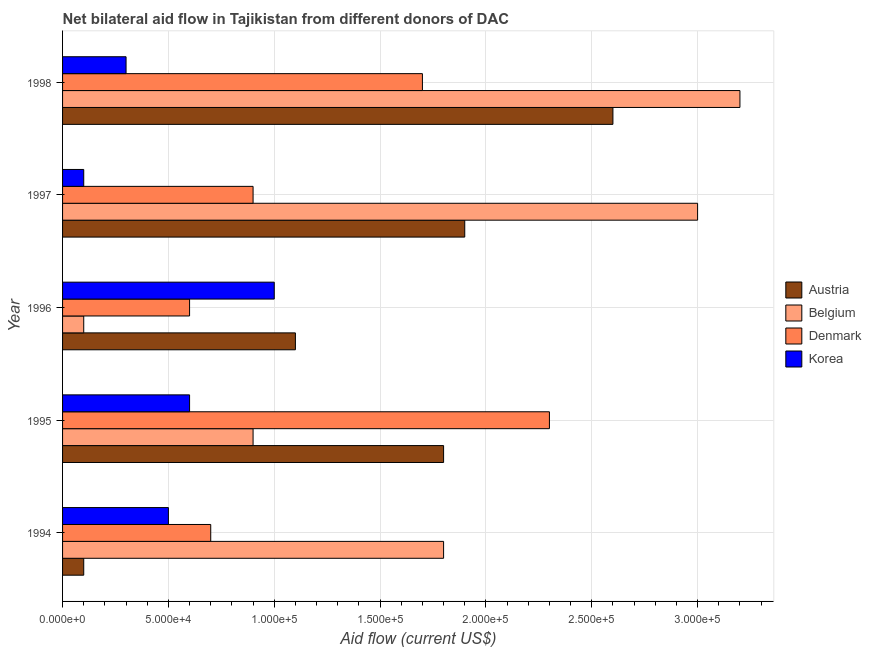How many different coloured bars are there?
Offer a terse response. 4. Are the number of bars per tick equal to the number of legend labels?
Your response must be concise. Yes. How many bars are there on the 1st tick from the top?
Provide a succinct answer. 4. How many bars are there on the 2nd tick from the bottom?
Make the answer very short. 4. What is the label of the 1st group of bars from the top?
Offer a terse response. 1998. What is the amount of aid given by korea in 1994?
Your answer should be very brief. 5.00e+04. Across all years, what is the maximum amount of aid given by korea?
Make the answer very short. 1.00e+05. Across all years, what is the minimum amount of aid given by austria?
Your response must be concise. 10000. What is the total amount of aid given by denmark in the graph?
Offer a very short reply. 6.20e+05. What is the difference between the amount of aid given by korea in 1996 and that in 1997?
Provide a succinct answer. 9.00e+04. What is the difference between the amount of aid given by austria in 1994 and the amount of aid given by denmark in 1996?
Offer a very short reply. -5.00e+04. In the year 1995, what is the difference between the amount of aid given by korea and amount of aid given by belgium?
Make the answer very short. -3.00e+04. In how many years, is the amount of aid given by korea greater than 40000 US$?
Provide a succinct answer. 3. Is the amount of aid given by korea in 1994 less than that in 1997?
Offer a very short reply. No. What is the difference between the highest and the second highest amount of aid given by korea?
Keep it short and to the point. 4.00e+04. What is the difference between the highest and the lowest amount of aid given by korea?
Ensure brevity in your answer.  9.00e+04. Is the sum of the amount of aid given by korea in 1995 and 1997 greater than the maximum amount of aid given by austria across all years?
Give a very brief answer. No. Is it the case that in every year, the sum of the amount of aid given by korea and amount of aid given by denmark is greater than the sum of amount of aid given by austria and amount of aid given by belgium?
Offer a very short reply. No. What does the 2nd bar from the top in 1997 represents?
Give a very brief answer. Denmark. What does the 1st bar from the bottom in 1997 represents?
Ensure brevity in your answer.  Austria. How many years are there in the graph?
Your answer should be very brief. 5. What is the difference between two consecutive major ticks on the X-axis?
Provide a short and direct response. 5.00e+04. Are the values on the major ticks of X-axis written in scientific E-notation?
Keep it short and to the point. Yes. Does the graph contain grids?
Your answer should be compact. Yes. Where does the legend appear in the graph?
Your answer should be very brief. Center right. How are the legend labels stacked?
Your answer should be very brief. Vertical. What is the title of the graph?
Your answer should be compact. Net bilateral aid flow in Tajikistan from different donors of DAC. What is the label or title of the X-axis?
Make the answer very short. Aid flow (current US$). What is the label or title of the Y-axis?
Provide a succinct answer. Year. What is the Aid flow (current US$) in Denmark in 1994?
Offer a very short reply. 7.00e+04. What is the Aid flow (current US$) in Korea in 1994?
Provide a short and direct response. 5.00e+04. What is the Aid flow (current US$) in Austria in 1995?
Your response must be concise. 1.80e+05. What is the Aid flow (current US$) in Denmark in 1995?
Give a very brief answer. 2.30e+05. What is the Aid flow (current US$) in Korea in 1995?
Your answer should be compact. 6.00e+04. What is the Aid flow (current US$) of Austria in 1996?
Your answer should be very brief. 1.10e+05. What is the Aid flow (current US$) of Belgium in 1997?
Provide a succinct answer. 3.00e+05. What is the Aid flow (current US$) of Denmark in 1997?
Your answer should be very brief. 9.00e+04. What is the Aid flow (current US$) of Korea in 1997?
Your answer should be very brief. 10000. What is the Aid flow (current US$) of Belgium in 1998?
Make the answer very short. 3.20e+05. Across all years, what is the maximum Aid flow (current US$) of Denmark?
Offer a terse response. 2.30e+05. Across all years, what is the maximum Aid flow (current US$) in Korea?
Keep it short and to the point. 1.00e+05. Across all years, what is the minimum Aid flow (current US$) in Austria?
Offer a very short reply. 10000. Across all years, what is the minimum Aid flow (current US$) in Belgium?
Ensure brevity in your answer.  10000. What is the total Aid flow (current US$) in Austria in the graph?
Your answer should be very brief. 7.50e+05. What is the total Aid flow (current US$) of Belgium in the graph?
Keep it short and to the point. 9.00e+05. What is the total Aid flow (current US$) in Denmark in the graph?
Provide a short and direct response. 6.20e+05. What is the difference between the Aid flow (current US$) of Austria in 1994 and that in 1995?
Ensure brevity in your answer.  -1.70e+05. What is the difference between the Aid flow (current US$) in Belgium in 1994 and that in 1995?
Keep it short and to the point. 9.00e+04. What is the difference between the Aid flow (current US$) in Korea in 1994 and that in 1995?
Your response must be concise. -10000. What is the difference between the Aid flow (current US$) in Belgium in 1994 and that in 1996?
Your response must be concise. 1.70e+05. What is the difference between the Aid flow (current US$) in Denmark in 1994 and that in 1996?
Ensure brevity in your answer.  10000. What is the difference between the Aid flow (current US$) in Belgium in 1994 and that in 1997?
Your answer should be compact. -1.20e+05. What is the difference between the Aid flow (current US$) in Denmark in 1994 and that in 1997?
Your answer should be compact. -2.00e+04. What is the difference between the Aid flow (current US$) of Korea in 1994 and that in 1997?
Your response must be concise. 4.00e+04. What is the difference between the Aid flow (current US$) in Austria in 1994 and that in 1998?
Ensure brevity in your answer.  -2.50e+05. What is the difference between the Aid flow (current US$) of Belgium in 1994 and that in 1998?
Provide a succinct answer. -1.40e+05. What is the difference between the Aid flow (current US$) of Korea in 1994 and that in 1998?
Provide a short and direct response. 2.00e+04. What is the difference between the Aid flow (current US$) of Austria in 1995 and that in 1996?
Your answer should be very brief. 7.00e+04. What is the difference between the Aid flow (current US$) of Belgium in 1995 and that in 1996?
Provide a short and direct response. 8.00e+04. What is the difference between the Aid flow (current US$) of Denmark in 1995 and that in 1996?
Provide a succinct answer. 1.70e+05. What is the difference between the Aid flow (current US$) in Korea in 1995 and that in 1996?
Keep it short and to the point. -4.00e+04. What is the difference between the Aid flow (current US$) of Austria in 1995 and that in 1997?
Your answer should be compact. -10000. What is the difference between the Aid flow (current US$) of Korea in 1995 and that in 1997?
Offer a very short reply. 5.00e+04. What is the difference between the Aid flow (current US$) in Korea in 1995 and that in 1998?
Provide a succinct answer. 3.00e+04. What is the difference between the Aid flow (current US$) of Denmark in 1996 and that in 1997?
Keep it short and to the point. -3.00e+04. What is the difference between the Aid flow (current US$) of Austria in 1996 and that in 1998?
Give a very brief answer. -1.50e+05. What is the difference between the Aid flow (current US$) in Belgium in 1996 and that in 1998?
Make the answer very short. -3.10e+05. What is the difference between the Aid flow (current US$) of Denmark in 1996 and that in 1998?
Ensure brevity in your answer.  -1.10e+05. What is the difference between the Aid flow (current US$) of Austria in 1994 and the Aid flow (current US$) of Belgium in 1995?
Offer a very short reply. -8.00e+04. What is the difference between the Aid flow (current US$) in Austria in 1994 and the Aid flow (current US$) in Denmark in 1995?
Your answer should be very brief. -2.20e+05. What is the difference between the Aid flow (current US$) of Austria in 1994 and the Aid flow (current US$) of Korea in 1995?
Offer a very short reply. -5.00e+04. What is the difference between the Aid flow (current US$) in Belgium in 1994 and the Aid flow (current US$) in Denmark in 1996?
Offer a terse response. 1.20e+05. What is the difference between the Aid flow (current US$) of Belgium in 1994 and the Aid flow (current US$) of Korea in 1996?
Ensure brevity in your answer.  8.00e+04. What is the difference between the Aid flow (current US$) in Denmark in 1994 and the Aid flow (current US$) in Korea in 1996?
Your answer should be very brief. -3.00e+04. What is the difference between the Aid flow (current US$) in Austria in 1994 and the Aid flow (current US$) in Korea in 1997?
Your answer should be very brief. 0. What is the difference between the Aid flow (current US$) of Denmark in 1994 and the Aid flow (current US$) of Korea in 1997?
Your response must be concise. 6.00e+04. What is the difference between the Aid flow (current US$) in Austria in 1994 and the Aid flow (current US$) in Belgium in 1998?
Offer a very short reply. -3.10e+05. What is the difference between the Aid flow (current US$) of Austria in 1994 and the Aid flow (current US$) of Denmark in 1998?
Your answer should be very brief. -1.60e+05. What is the difference between the Aid flow (current US$) of Belgium in 1994 and the Aid flow (current US$) of Korea in 1998?
Provide a short and direct response. 1.50e+05. What is the difference between the Aid flow (current US$) in Austria in 1995 and the Aid flow (current US$) in Belgium in 1996?
Ensure brevity in your answer.  1.70e+05. What is the difference between the Aid flow (current US$) of Belgium in 1995 and the Aid flow (current US$) of Denmark in 1996?
Your response must be concise. 3.00e+04. What is the difference between the Aid flow (current US$) in Belgium in 1995 and the Aid flow (current US$) in Korea in 1996?
Provide a short and direct response. -10000. What is the difference between the Aid flow (current US$) of Austria in 1995 and the Aid flow (current US$) of Denmark in 1997?
Ensure brevity in your answer.  9.00e+04. What is the difference between the Aid flow (current US$) in Belgium in 1995 and the Aid flow (current US$) in Denmark in 1997?
Provide a succinct answer. 0. What is the difference between the Aid flow (current US$) in Belgium in 1995 and the Aid flow (current US$) in Korea in 1997?
Offer a very short reply. 8.00e+04. What is the difference between the Aid flow (current US$) in Austria in 1995 and the Aid flow (current US$) in Korea in 1998?
Your answer should be very brief. 1.50e+05. What is the difference between the Aid flow (current US$) of Belgium in 1995 and the Aid flow (current US$) of Denmark in 1998?
Your answer should be compact. -8.00e+04. What is the difference between the Aid flow (current US$) in Belgium in 1995 and the Aid flow (current US$) in Korea in 1998?
Offer a very short reply. 6.00e+04. What is the difference between the Aid flow (current US$) in Denmark in 1995 and the Aid flow (current US$) in Korea in 1998?
Your response must be concise. 2.00e+05. What is the difference between the Aid flow (current US$) of Austria in 1996 and the Aid flow (current US$) of Belgium in 1997?
Offer a terse response. -1.90e+05. What is the difference between the Aid flow (current US$) in Austria in 1996 and the Aid flow (current US$) in Denmark in 1997?
Provide a succinct answer. 2.00e+04. What is the difference between the Aid flow (current US$) of Belgium in 1996 and the Aid flow (current US$) of Denmark in 1997?
Provide a succinct answer. -8.00e+04. What is the difference between the Aid flow (current US$) of Denmark in 1996 and the Aid flow (current US$) of Korea in 1997?
Your answer should be very brief. 5.00e+04. What is the difference between the Aid flow (current US$) of Austria in 1996 and the Aid flow (current US$) of Belgium in 1998?
Offer a terse response. -2.10e+05. What is the difference between the Aid flow (current US$) in Austria in 1996 and the Aid flow (current US$) in Denmark in 1998?
Offer a very short reply. -6.00e+04. What is the difference between the Aid flow (current US$) of Austria in 1996 and the Aid flow (current US$) of Korea in 1998?
Provide a short and direct response. 8.00e+04. What is the difference between the Aid flow (current US$) in Belgium in 1996 and the Aid flow (current US$) in Denmark in 1998?
Your answer should be very brief. -1.60e+05. What is the difference between the Aid flow (current US$) of Belgium in 1996 and the Aid flow (current US$) of Korea in 1998?
Ensure brevity in your answer.  -2.00e+04. What is the difference between the Aid flow (current US$) of Denmark in 1996 and the Aid flow (current US$) of Korea in 1998?
Provide a short and direct response. 3.00e+04. What is the difference between the Aid flow (current US$) of Belgium in 1997 and the Aid flow (current US$) of Korea in 1998?
Provide a short and direct response. 2.70e+05. What is the average Aid flow (current US$) in Austria per year?
Ensure brevity in your answer.  1.50e+05. What is the average Aid flow (current US$) of Denmark per year?
Provide a short and direct response. 1.24e+05. In the year 1994, what is the difference between the Aid flow (current US$) in Belgium and Aid flow (current US$) in Denmark?
Offer a terse response. 1.10e+05. In the year 1995, what is the difference between the Aid flow (current US$) of Belgium and Aid flow (current US$) of Korea?
Ensure brevity in your answer.  3.00e+04. In the year 1995, what is the difference between the Aid flow (current US$) of Denmark and Aid flow (current US$) of Korea?
Provide a succinct answer. 1.70e+05. In the year 1996, what is the difference between the Aid flow (current US$) in Austria and Aid flow (current US$) in Denmark?
Keep it short and to the point. 5.00e+04. In the year 1996, what is the difference between the Aid flow (current US$) in Austria and Aid flow (current US$) in Korea?
Your response must be concise. 10000. In the year 1996, what is the difference between the Aid flow (current US$) of Belgium and Aid flow (current US$) of Denmark?
Give a very brief answer. -5.00e+04. In the year 1997, what is the difference between the Aid flow (current US$) in Austria and Aid flow (current US$) in Belgium?
Ensure brevity in your answer.  -1.10e+05. In the year 1997, what is the difference between the Aid flow (current US$) in Austria and Aid flow (current US$) in Denmark?
Offer a terse response. 1.00e+05. In the year 1997, what is the difference between the Aid flow (current US$) of Austria and Aid flow (current US$) of Korea?
Your response must be concise. 1.80e+05. In the year 1997, what is the difference between the Aid flow (current US$) in Belgium and Aid flow (current US$) in Denmark?
Ensure brevity in your answer.  2.10e+05. In the year 1997, what is the difference between the Aid flow (current US$) of Belgium and Aid flow (current US$) of Korea?
Give a very brief answer. 2.90e+05. In the year 1998, what is the difference between the Aid flow (current US$) of Austria and Aid flow (current US$) of Belgium?
Your response must be concise. -6.00e+04. In the year 1998, what is the difference between the Aid flow (current US$) of Austria and Aid flow (current US$) of Denmark?
Make the answer very short. 9.00e+04. In the year 1998, what is the difference between the Aid flow (current US$) in Belgium and Aid flow (current US$) in Denmark?
Make the answer very short. 1.50e+05. In the year 1998, what is the difference between the Aid flow (current US$) of Belgium and Aid flow (current US$) of Korea?
Offer a very short reply. 2.90e+05. In the year 1998, what is the difference between the Aid flow (current US$) of Denmark and Aid flow (current US$) of Korea?
Offer a terse response. 1.40e+05. What is the ratio of the Aid flow (current US$) in Austria in 1994 to that in 1995?
Make the answer very short. 0.06. What is the ratio of the Aid flow (current US$) in Belgium in 1994 to that in 1995?
Your response must be concise. 2. What is the ratio of the Aid flow (current US$) in Denmark in 1994 to that in 1995?
Make the answer very short. 0.3. What is the ratio of the Aid flow (current US$) in Korea in 1994 to that in 1995?
Make the answer very short. 0.83. What is the ratio of the Aid flow (current US$) of Austria in 1994 to that in 1996?
Keep it short and to the point. 0.09. What is the ratio of the Aid flow (current US$) in Denmark in 1994 to that in 1996?
Ensure brevity in your answer.  1.17. What is the ratio of the Aid flow (current US$) of Austria in 1994 to that in 1997?
Make the answer very short. 0.05. What is the ratio of the Aid flow (current US$) in Denmark in 1994 to that in 1997?
Make the answer very short. 0.78. What is the ratio of the Aid flow (current US$) in Austria in 1994 to that in 1998?
Provide a succinct answer. 0.04. What is the ratio of the Aid flow (current US$) in Belgium in 1994 to that in 1998?
Provide a succinct answer. 0.56. What is the ratio of the Aid flow (current US$) in Denmark in 1994 to that in 1998?
Your response must be concise. 0.41. What is the ratio of the Aid flow (current US$) in Korea in 1994 to that in 1998?
Offer a terse response. 1.67. What is the ratio of the Aid flow (current US$) in Austria in 1995 to that in 1996?
Make the answer very short. 1.64. What is the ratio of the Aid flow (current US$) in Belgium in 1995 to that in 1996?
Offer a terse response. 9. What is the ratio of the Aid flow (current US$) in Denmark in 1995 to that in 1996?
Provide a succinct answer. 3.83. What is the ratio of the Aid flow (current US$) of Austria in 1995 to that in 1997?
Offer a very short reply. 0.95. What is the ratio of the Aid flow (current US$) of Belgium in 1995 to that in 1997?
Offer a terse response. 0.3. What is the ratio of the Aid flow (current US$) in Denmark in 1995 to that in 1997?
Give a very brief answer. 2.56. What is the ratio of the Aid flow (current US$) in Korea in 1995 to that in 1997?
Keep it short and to the point. 6. What is the ratio of the Aid flow (current US$) of Austria in 1995 to that in 1998?
Provide a succinct answer. 0.69. What is the ratio of the Aid flow (current US$) in Belgium in 1995 to that in 1998?
Ensure brevity in your answer.  0.28. What is the ratio of the Aid flow (current US$) of Denmark in 1995 to that in 1998?
Your answer should be very brief. 1.35. What is the ratio of the Aid flow (current US$) of Austria in 1996 to that in 1997?
Your response must be concise. 0.58. What is the ratio of the Aid flow (current US$) of Austria in 1996 to that in 1998?
Make the answer very short. 0.42. What is the ratio of the Aid flow (current US$) of Belgium in 1996 to that in 1998?
Your answer should be very brief. 0.03. What is the ratio of the Aid flow (current US$) in Denmark in 1996 to that in 1998?
Your answer should be compact. 0.35. What is the ratio of the Aid flow (current US$) of Korea in 1996 to that in 1998?
Your response must be concise. 3.33. What is the ratio of the Aid flow (current US$) in Austria in 1997 to that in 1998?
Offer a very short reply. 0.73. What is the ratio of the Aid flow (current US$) in Belgium in 1997 to that in 1998?
Your answer should be compact. 0.94. What is the ratio of the Aid flow (current US$) of Denmark in 1997 to that in 1998?
Offer a very short reply. 0.53. What is the ratio of the Aid flow (current US$) of Korea in 1997 to that in 1998?
Give a very brief answer. 0.33. What is the difference between the highest and the second highest Aid flow (current US$) in Austria?
Make the answer very short. 7.00e+04. What is the difference between the highest and the second highest Aid flow (current US$) of Korea?
Provide a short and direct response. 4.00e+04. What is the difference between the highest and the lowest Aid flow (current US$) in Denmark?
Keep it short and to the point. 1.70e+05. What is the difference between the highest and the lowest Aid flow (current US$) in Korea?
Provide a succinct answer. 9.00e+04. 